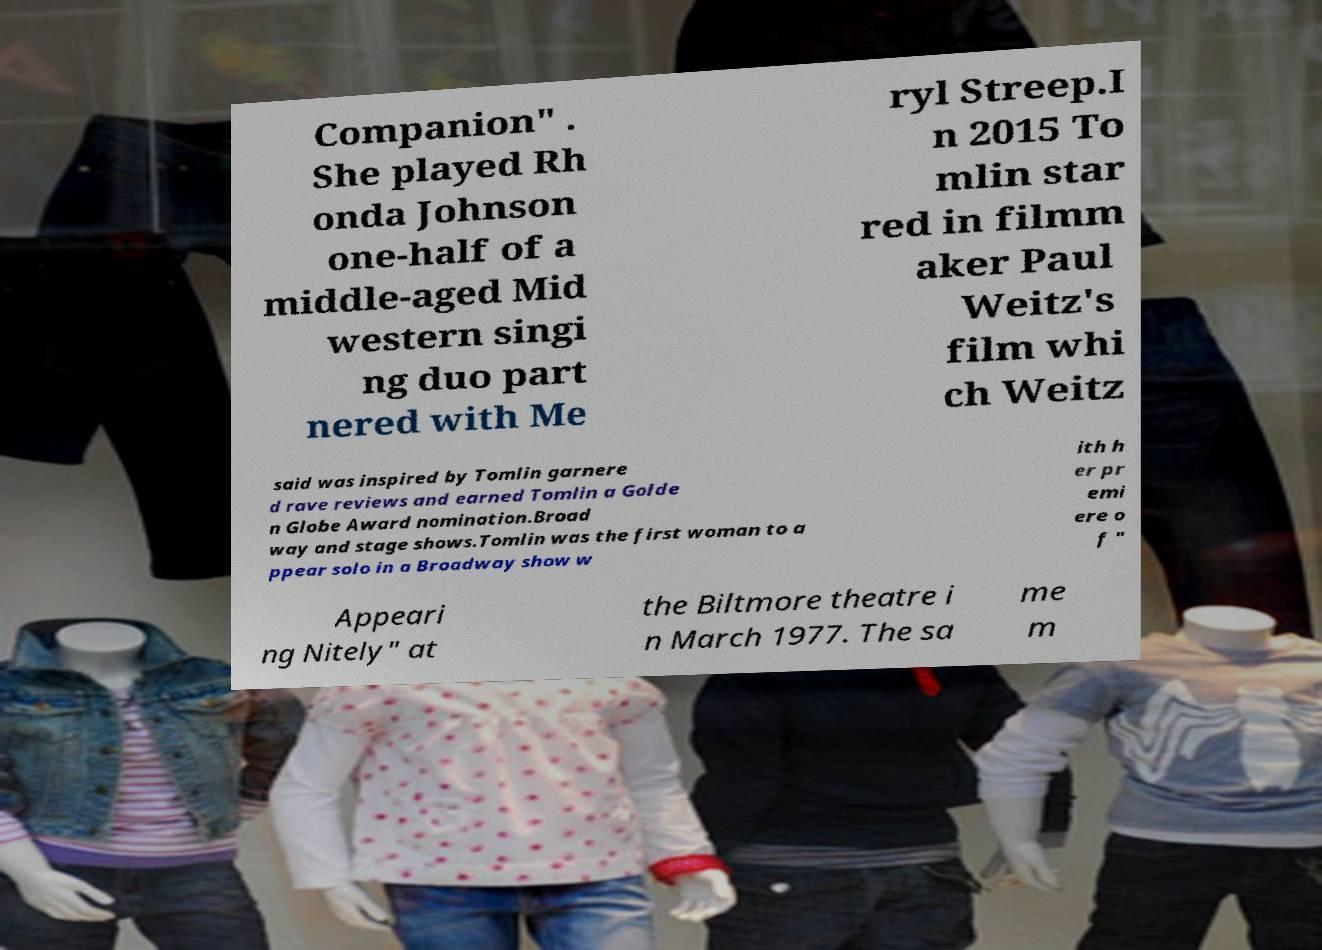Could you extract and type out the text from this image? Companion" . She played Rh onda Johnson one-half of a middle-aged Mid western singi ng duo part nered with Me ryl Streep.I n 2015 To mlin star red in filmm aker Paul Weitz's film whi ch Weitz said was inspired by Tomlin garnere d rave reviews and earned Tomlin a Golde n Globe Award nomination.Broad way and stage shows.Tomlin was the first woman to a ppear solo in a Broadway show w ith h er pr emi ere o f " Appeari ng Nitely" at the Biltmore theatre i n March 1977. The sa me m 